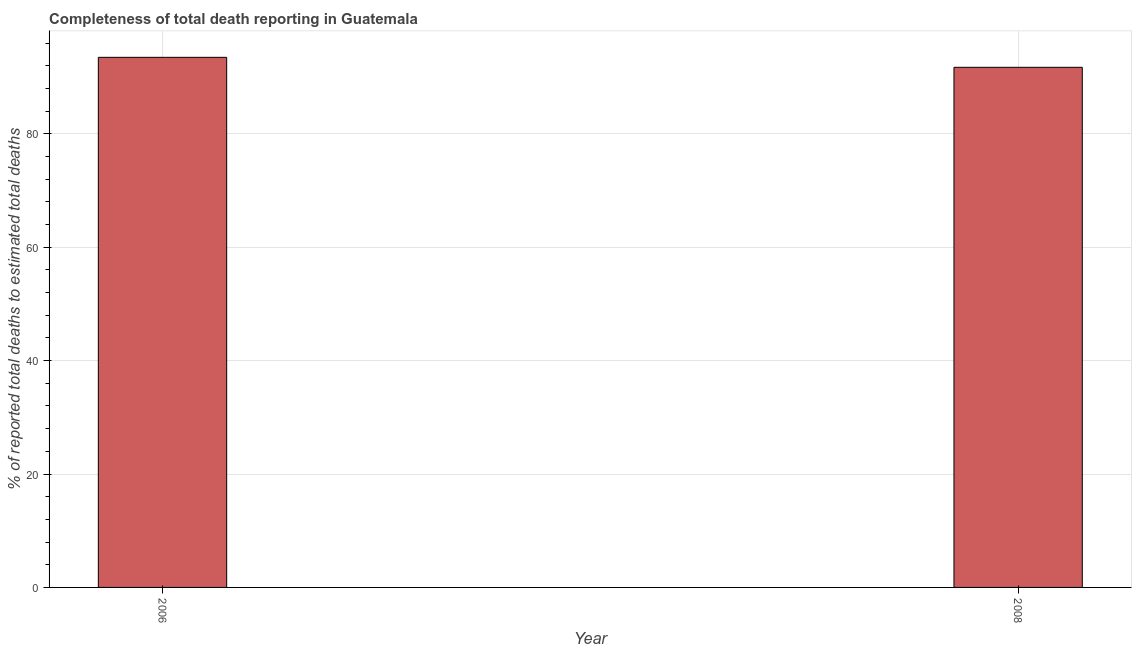Does the graph contain any zero values?
Offer a terse response. No. Does the graph contain grids?
Your answer should be compact. Yes. What is the title of the graph?
Offer a terse response. Completeness of total death reporting in Guatemala. What is the label or title of the Y-axis?
Offer a terse response. % of reported total deaths to estimated total deaths. What is the completeness of total death reports in 2008?
Your answer should be very brief. 91.73. Across all years, what is the maximum completeness of total death reports?
Keep it short and to the point. 93.48. Across all years, what is the minimum completeness of total death reports?
Make the answer very short. 91.73. In which year was the completeness of total death reports maximum?
Ensure brevity in your answer.  2006. In which year was the completeness of total death reports minimum?
Offer a terse response. 2008. What is the sum of the completeness of total death reports?
Your answer should be very brief. 185.21. What is the difference between the completeness of total death reports in 2006 and 2008?
Your response must be concise. 1.76. What is the average completeness of total death reports per year?
Offer a terse response. 92.61. What is the median completeness of total death reports?
Your answer should be compact. 92.61. Do a majority of the years between 2008 and 2006 (inclusive) have completeness of total death reports greater than 60 %?
Ensure brevity in your answer.  No. What is the ratio of the completeness of total death reports in 2006 to that in 2008?
Ensure brevity in your answer.  1.02. Is the completeness of total death reports in 2006 less than that in 2008?
Ensure brevity in your answer.  No. How many years are there in the graph?
Your answer should be very brief. 2. What is the difference between two consecutive major ticks on the Y-axis?
Provide a succinct answer. 20. Are the values on the major ticks of Y-axis written in scientific E-notation?
Keep it short and to the point. No. What is the % of reported total deaths to estimated total deaths in 2006?
Make the answer very short. 93.48. What is the % of reported total deaths to estimated total deaths of 2008?
Your answer should be very brief. 91.73. What is the difference between the % of reported total deaths to estimated total deaths in 2006 and 2008?
Your answer should be very brief. 1.76. What is the ratio of the % of reported total deaths to estimated total deaths in 2006 to that in 2008?
Provide a succinct answer. 1.02. 